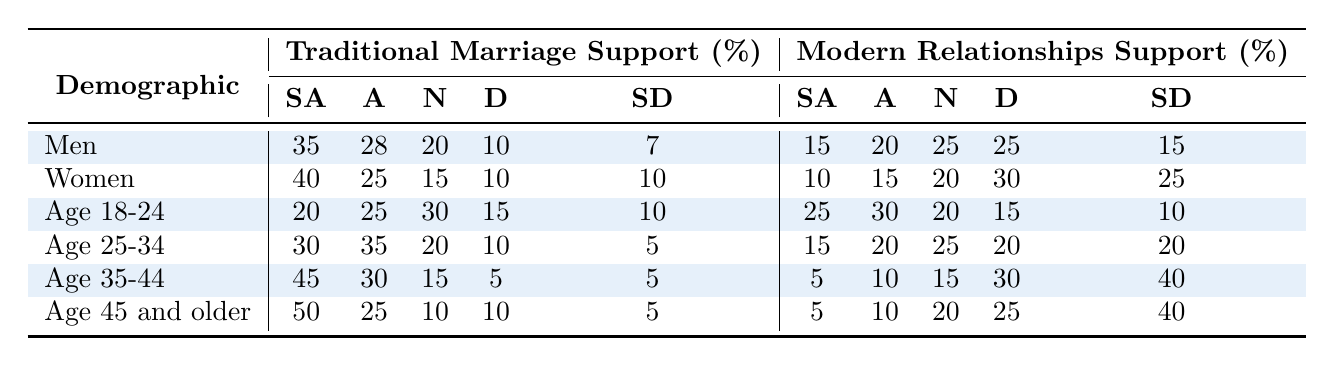What percentage of men strongly agree with traditional marriage? Looking at the "Men" row under the "Traditional Marriage Support" section, it shows that 35% of men strongly agree.
Answer: 35% What is the total percentage of women who support traditional marriage (strongly agree and agree combined)? For women, the "Strongly Agree" percentage is 40% and the "Agree" percentage is 25%. Adding them gives 40 + 25 = 65%.
Answer: 65% Which age group has the highest support for traditional marriage? Referring to the "Traditional Marriage Support" section, the "Age 45 and older" row shows the highest "Strongly Agree" percentage at 50%.
Answer: Age 45 and older What is the difference between the percentage of men who strongly agree with traditional marriage and those who strongly agree with modern relationships? Men have 35% strongly agree with traditional marriage and 15% strongly agree with modern relationships. The difference is 35 - 15 = 20%.
Answer: 20% What percentage of men and women agree with modern relationships when combined? Men have 20% agreeing and women have 15% agreeing with modern relationships. Adding these gives 20 + 15 = 35%.
Answer: 35% What is the median percentage of support for traditional marriage among all demographics? Listing "Strongly Agree" for each demographic (35, 40, 20, 30, 45, 50), we arrange the values: 20, 30, 35, 40, 45, 50. The median is the average of the two middle values: (35 + 40)/2 = 37.5%.
Answer: 37.5% Is it true that the majority of those aged 35-44 disagree with modern relationships? The "Disagree" percentage for "Age 35-44" is 30%. Since this is higher than "Agree" (10%), the statement is true.
Answer: Yes Which demographic shows the highest percentage of neutrality towards modern relationships? Looking at the "Modern Relationships Support" section, "Age 25-34" has the highest neutral percentage at 25%.
Answer: Age 25-34 How much more do women strongly agree with traditional marriage compared to women who support modern relationships? Women strongly agree with traditional marriage at 40% and strongly agree with modern relationships at 10%. The difference is 40 - 10 = 30%.
Answer: 30% In which age group do more people strongly agree with modern relationships than with traditional marriage? The "Age 18-24" group shows 25% strongly agreeing with modern relationships compared to 20% for traditional marriage; thus, more people in this age group support modern relationships.
Answer: Age 18-24 